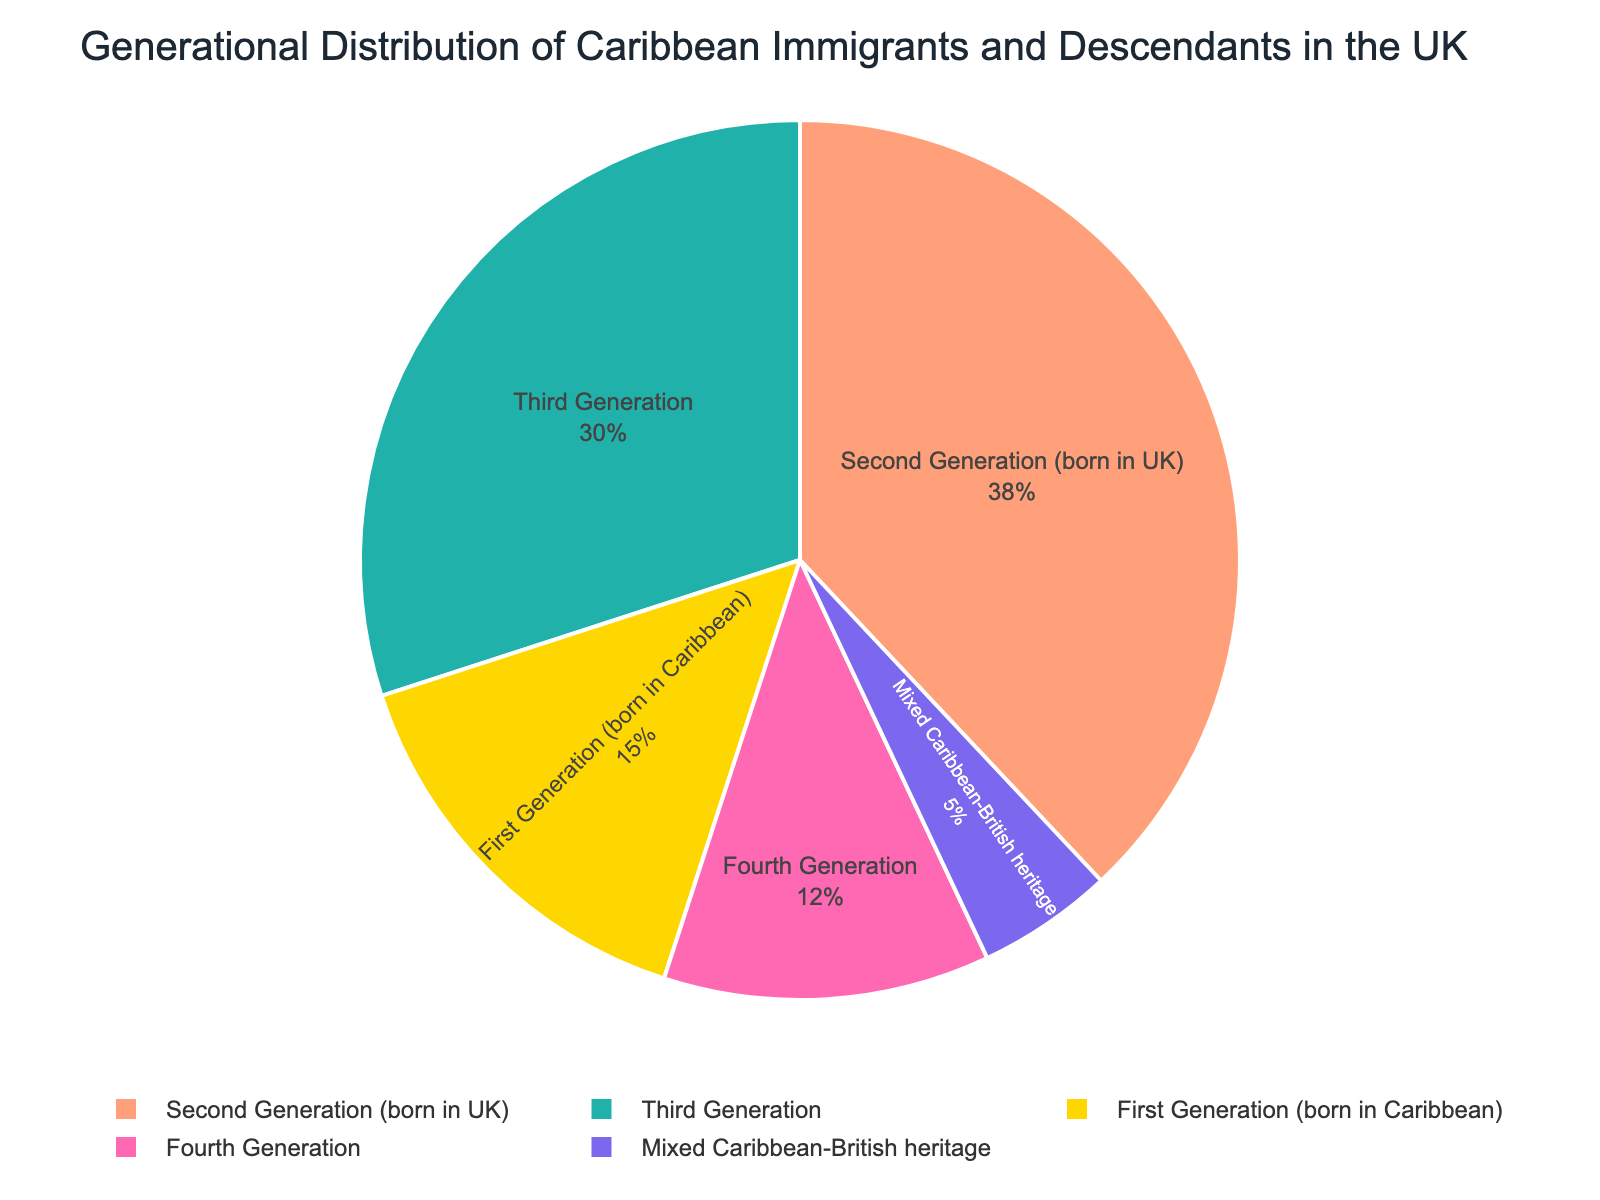What percentage of Caribbean immigrants and their descendants in the UK are first-generation immigrants? The pie chart shows that the section labeled "First Generation (born in Caribbean)" constitutes 15% of the total population.
Answer: 15% What percentage of Caribbean immigrants and their descendants in the UK are second-generation? The pie chart displays that the section labeled "Second Generation (born in UK)" forms 38% of the total population.
Answer: 38% Which generation has the smallest representation in the pie chart? By looking at the pie chart, the sector labeled "Mixed Caribbean-British heritage" is the smallest, constituting 5% of the total population.
Answer: Mixed Caribbean-British heritage How much larger is the percentage of second-generation individuals compared to first-generation individuals? The chart shows that second-generation individuals account for 38%, and first-generation individuals account for 15%. The difference is 38% - 15% = 23%.
Answer: 23% Which generation has a higher percentage, the third or fourth generation? The pie chart depicts that the third generation is 30%, whereas the fourth generation is 12%. Hence, the third generation has a higher percentage.
Answer: Third Generation What is the combined percentage of third and fourth-generation individuals? According to the pie chart, the third generation is 30% and the fourth generation is 12%. The combined percentage is 30% + 12% = 42%.
Answer: 42% Is the percentage of mixed Caribbean-British heritage individuals more or less than 10%? The pie chart indicates that the mixed Caribbean-British heritage section is 5%, which is less than 10%.
Answer: Less What is the sum of the percentages of first and fourth-generation individuals? The pie chart shows that the first generation is 15% and the fourth generation is 12%. The sum is 15% + 12% = 27%.
Answer: 27% Which generation has a larger share, first or third-generation individuals? Observing the pie chart, the first generation is 15%, while the third generation is 30%. Therefore, the third generation has a larger share.
Answer: Third Generation How many generations and categories are represented in the pie chart? The pie chart features five distinct labeled sections: first generation, second generation, third generation, fourth generation, and mixed Caribbean-British heritage.
Answer: Five 